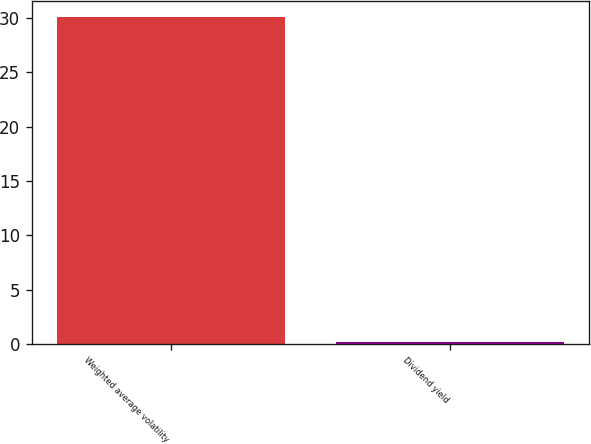Convert chart. <chart><loc_0><loc_0><loc_500><loc_500><bar_chart><fcel>Weighted average volatility<fcel>Dividend yield<nl><fcel>30.1<fcel>0.2<nl></chart> 